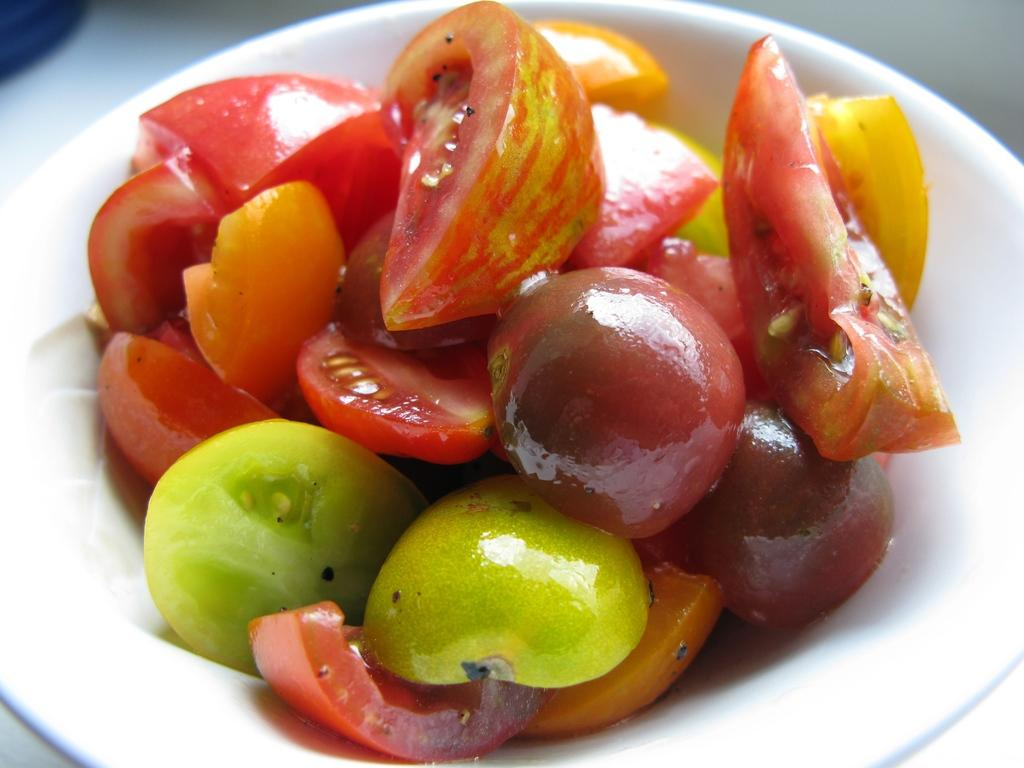What type of food can be seen in the image? There are vegetables in the image. How are the vegetables arranged or contained in the image? The vegetables are in a bowl. What type of dress is the vegetable wearing in the image? There are no vegetables wearing dresses in the image, as vegetables are not capable of wearing clothing. 